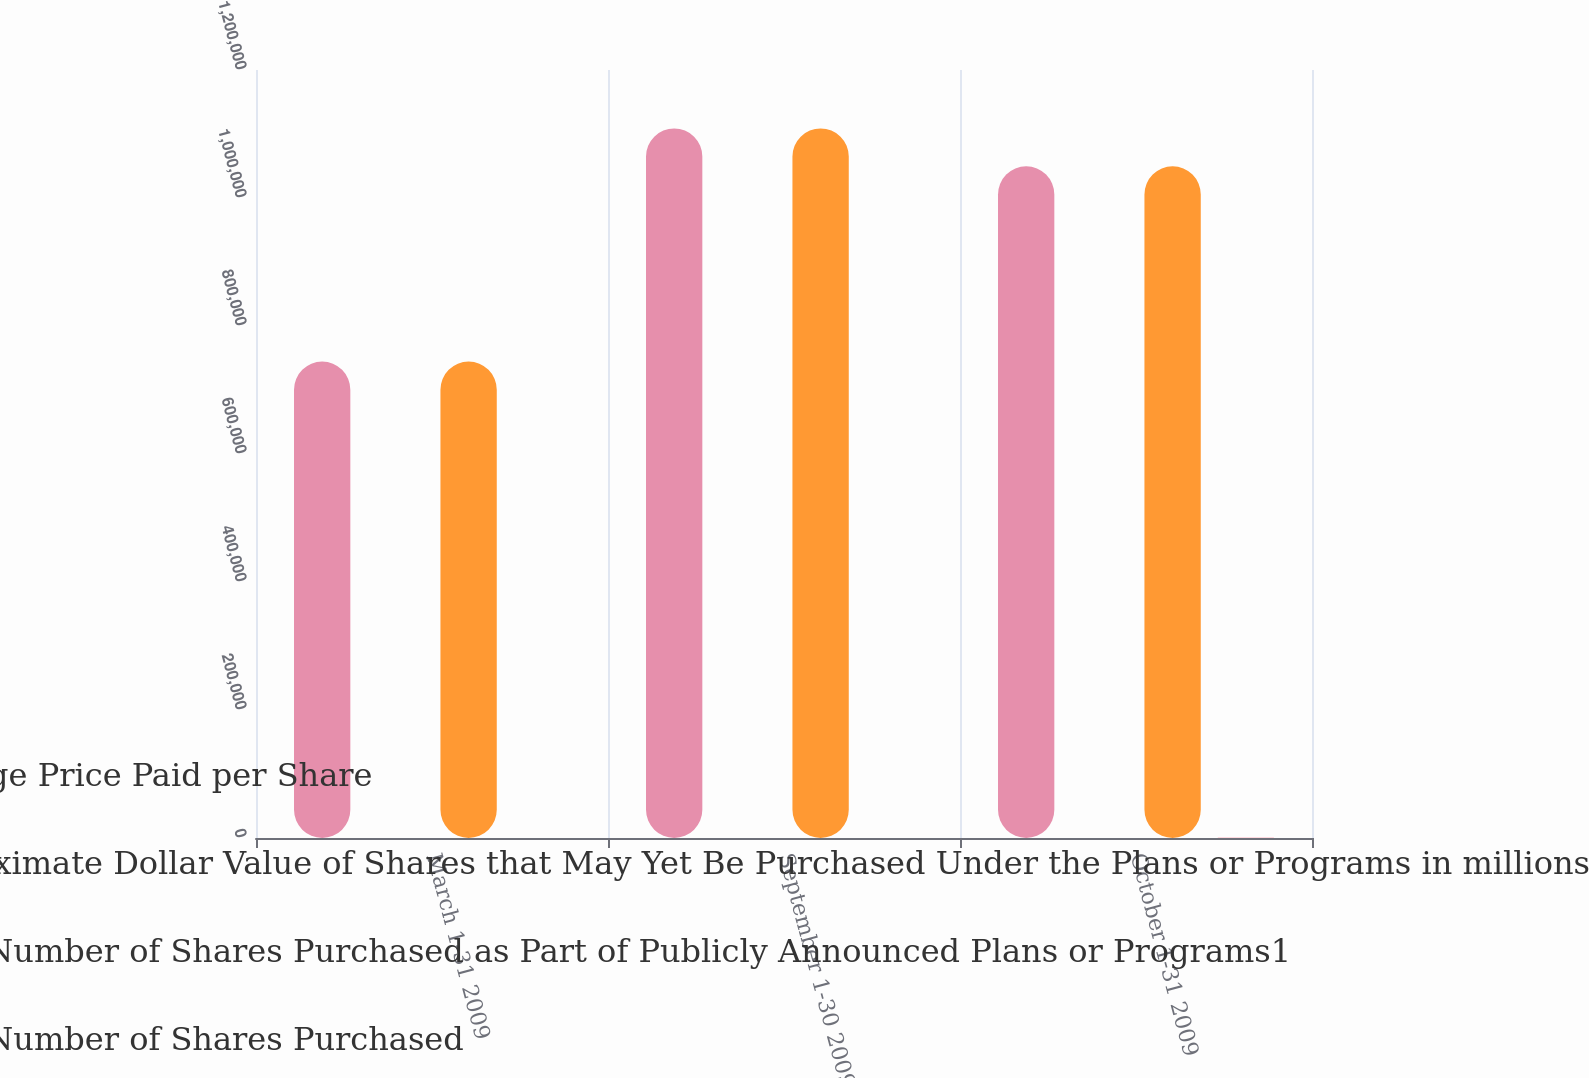Convert chart. <chart><loc_0><loc_0><loc_500><loc_500><stacked_bar_chart><ecel><fcel>March 1-31 2009<fcel>September 1-30 2009<fcel>October 1-31 2009<nl><fcel>Average Price Paid per Share<fcel>744400<fcel>1.10878e+06<fcel>1.04944e+06<nl><fcel>Approximate Dollar Value of Shares that May Yet Be Purchased Under the Plans or Programs in millions<fcel>43.01<fcel>56.25<fcel>56.32<nl><fcel>Total Number of Shares Purchased as Part of Publicly Announced Plans or Programs1<fcel>744400<fcel>1.10878e+06<fcel>1.04944e+06<nl><fcel>Total Number of Shares Purchased<fcel>121.5<fcel>59.1<fcel>500<nl></chart> 